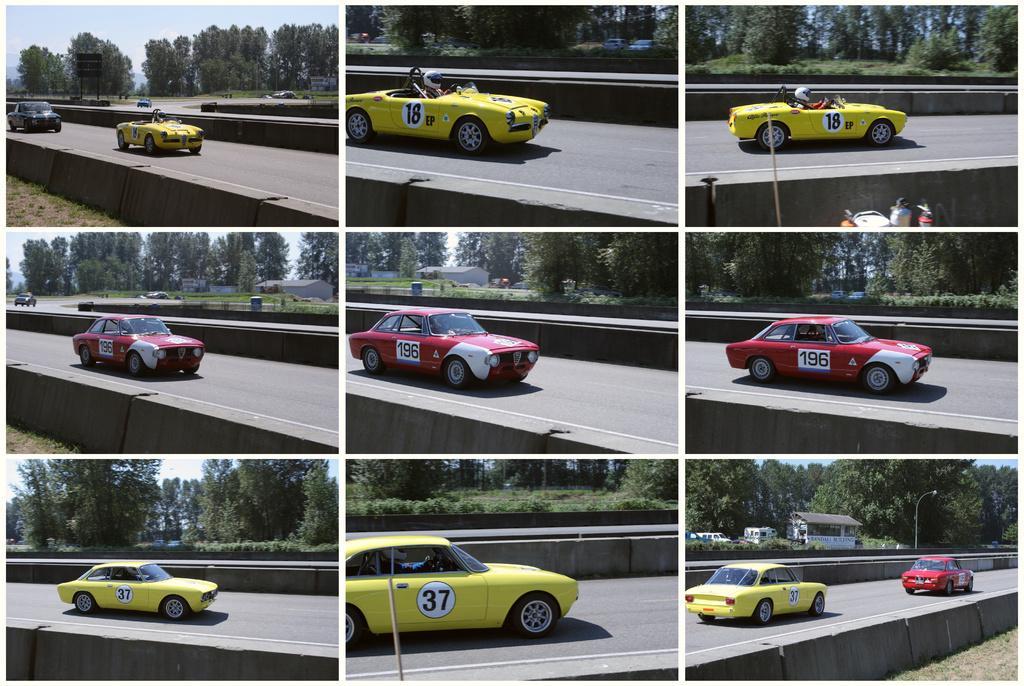In one or two sentences, can you explain what this image depicts? This is a collage image. In this image I can see nine pictures. In every picture, I can see the cars on the road. In the background there are many trees and buildings. At the top of these pictures, I can see the sky. 